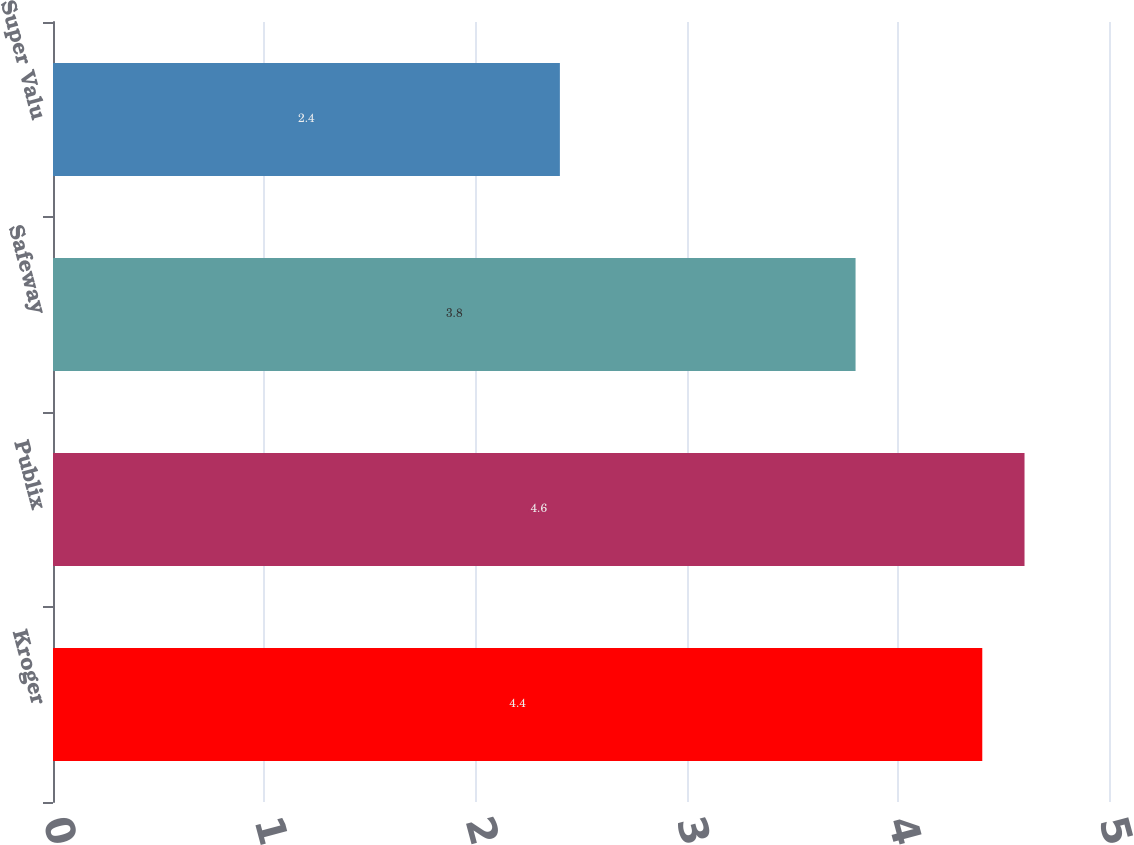Convert chart to OTSL. <chart><loc_0><loc_0><loc_500><loc_500><bar_chart><fcel>Kroger<fcel>Publix<fcel>Safeway<fcel>Super Valu<nl><fcel>4.4<fcel>4.6<fcel>3.8<fcel>2.4<nl></chart> 